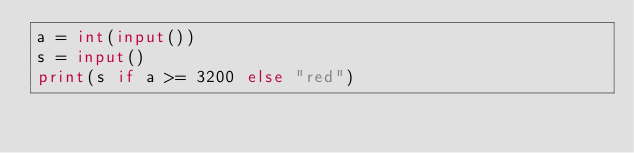Convert code to text. <code><loc_0><loc_0><loc_500><loc_500><_Python_>a = int(input())
s = input()
print(s if a >= 3200 else "red")
</code> 